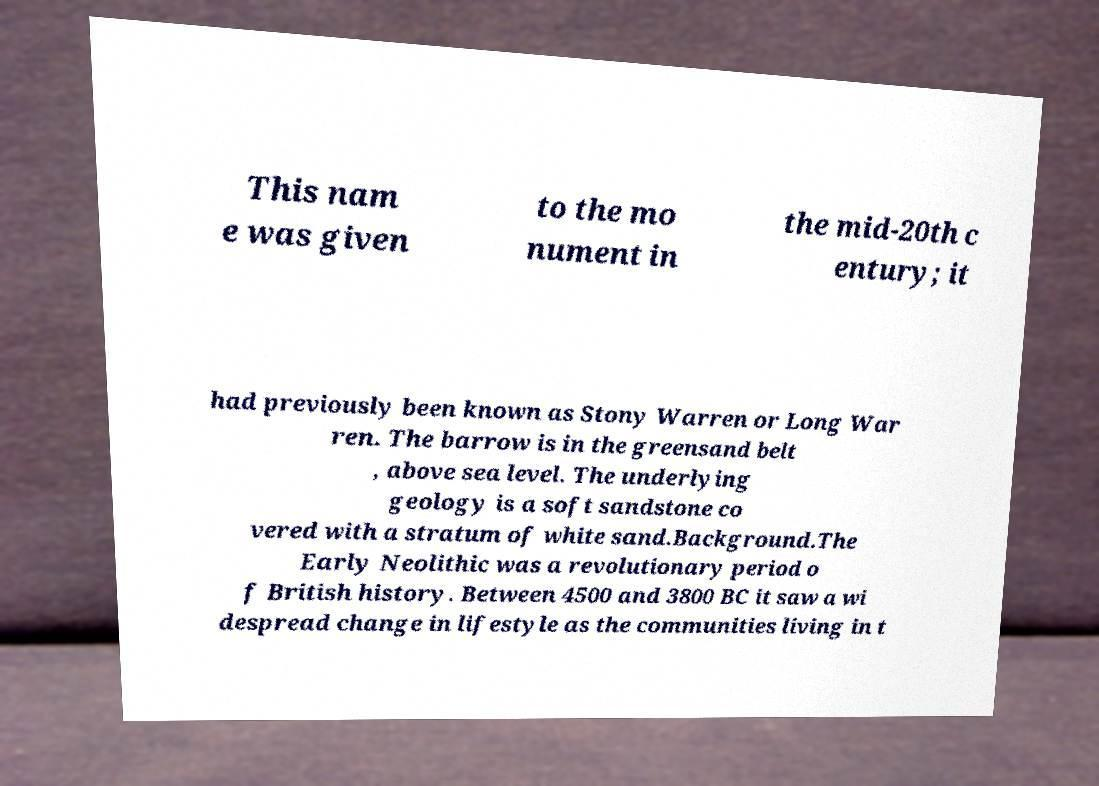Could you assist in decoding the text presented in this image and type it out clearly? This nam e was given to the mo nument in the mid-20th c entury; it had previously been known as Stony Warren or Long War ren. The barrow is in the greensand belt , above sea level. The underlying geology is a soft sandstone co vered with a stratum of white sand.Background.The Early Neolithic was a revolutionary period o f British history. Between 4500 and 3800 BC it saw a wi despread change in lifestyle as the communities living in t 